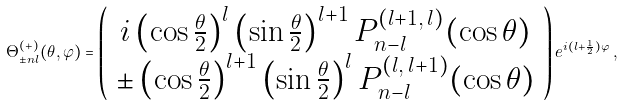Convert formula to latex. <formula><loc_0><loc_0><loc_500><loc_500>\Theta ^ { ( + ) } _ { \pm n l } ( \theta , \varphi ) = \left ( \begin{array} { c } i \left ( \cos \frac { \theta } { 2 } \right ) ^ { l } \left ( \sin \frac { \theta } { 2 } \right ) ^ { l + 1 } P ^ { ( l + 1 , \, l ) } _ { n - l } ( \cos \theta ) \\ \pm \left ( \cos \frac { \theta } { 2 } \right ) ^ { l + 1 } \left ( \sin \frac { \theta } { 2 } \right ) ^ { l } P ^ { ( l , \, l + 1 ) } _ { n - l } ( \cos \theta ) \end{array} \right ) e ^ { i ( l + \frac { 1 } { 2 } ) \varphi } \, ,</formula> 